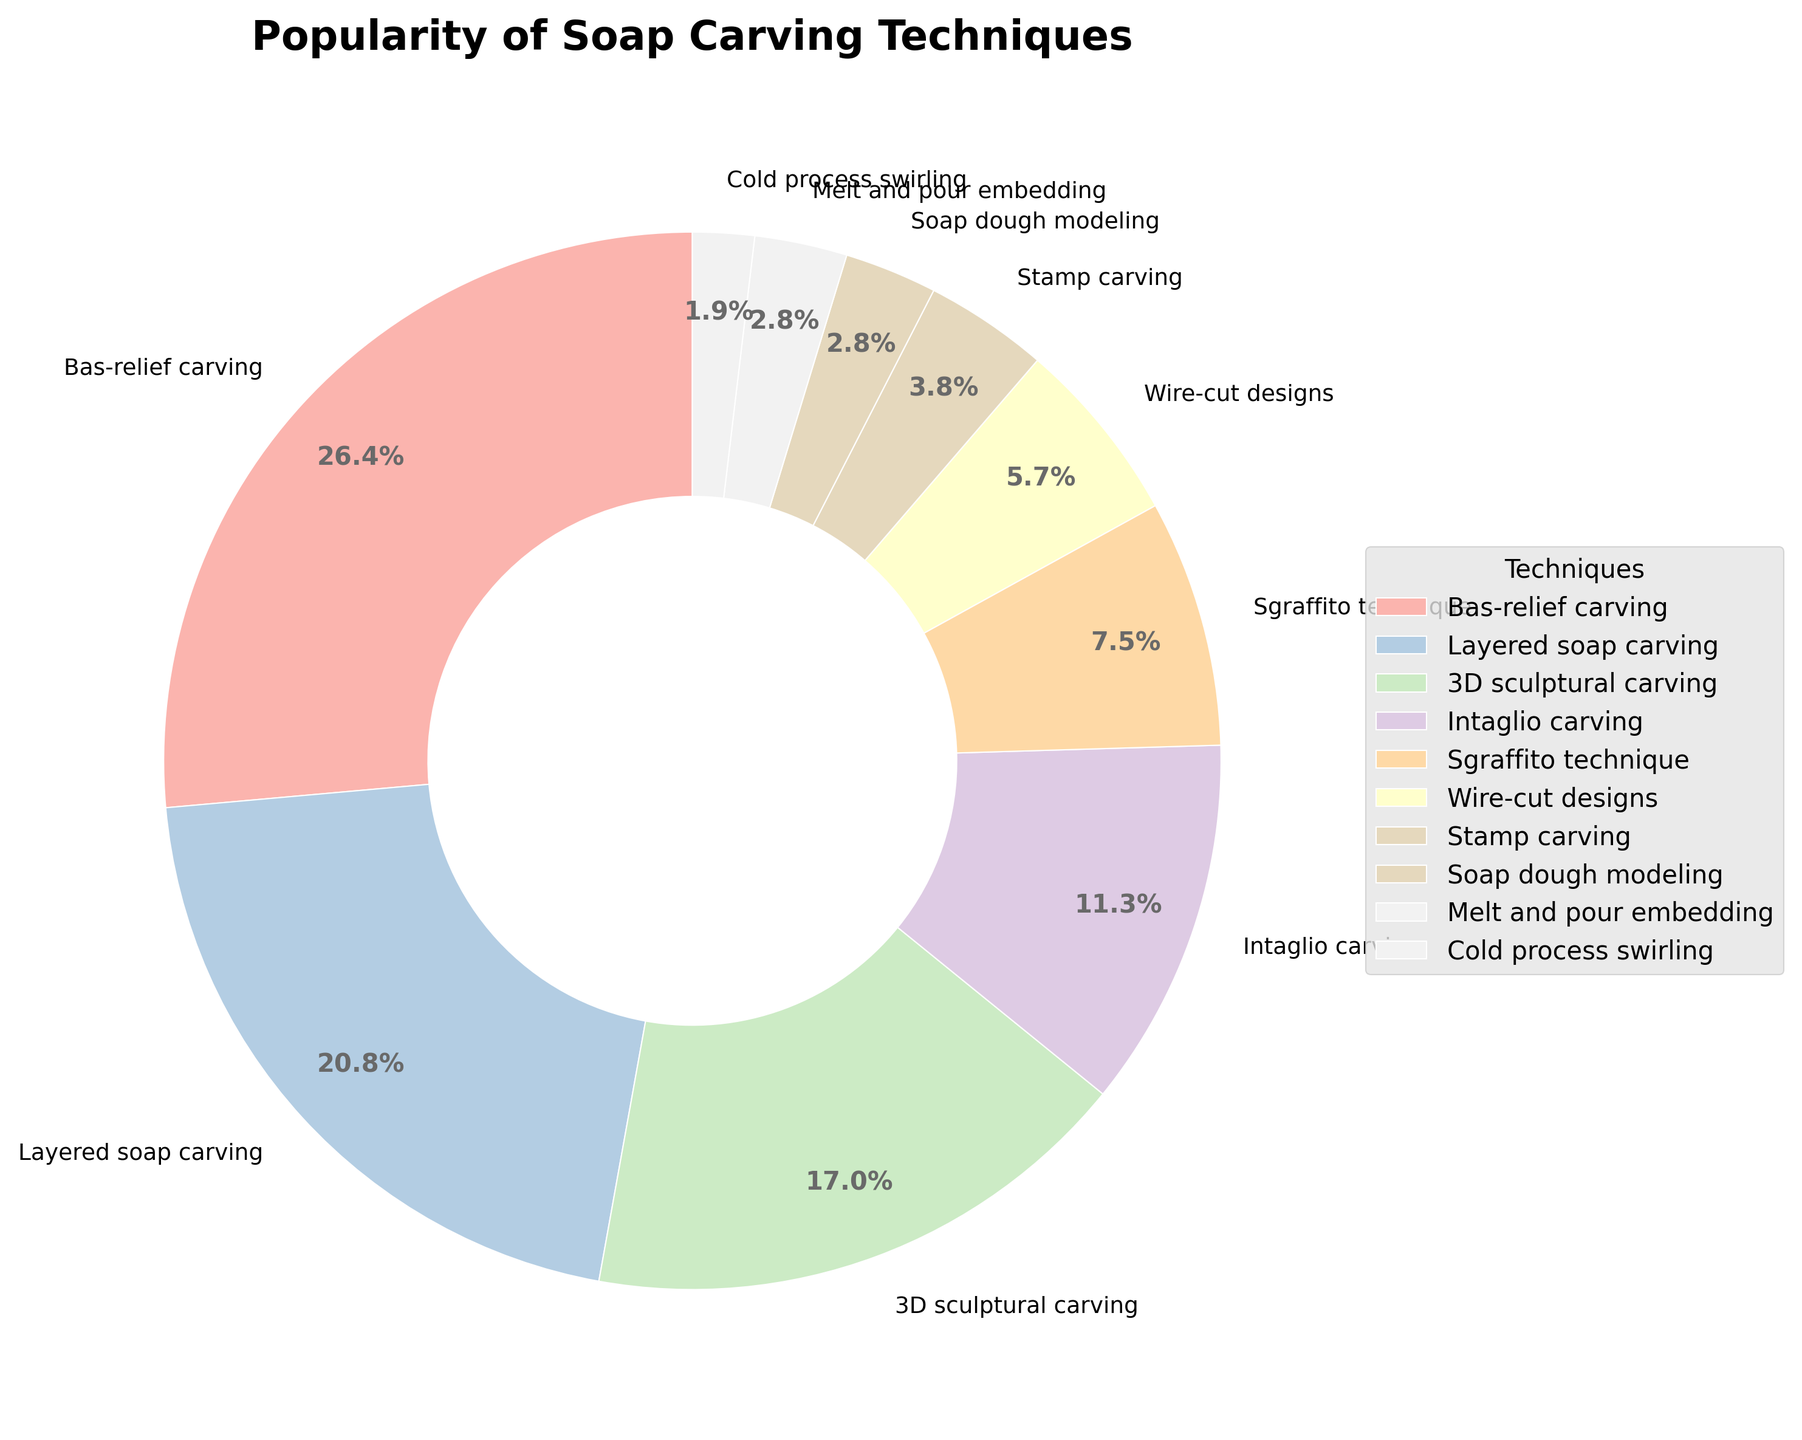Which soap carving technique is the most popular? To determine the most popular technique, we look at the segment of the pie chart with the largest percentage. Bas-relief carving occupies the largest segment with 28%.
Answer: Bas-relief carving How much more popular is layered soap carving compared to wire-cut designs? Layered soap carving has 22% while wire-cut designs have 6%. Subtracting the percentage of wire-cut designs from layered soap carving gives us the difference: 22% - 6% = 16%.
Answer: 16% Which two techniques combined account for less than 10% of the total? By examining the pie chart, we find that Stamp carving and Soap dough modeling both have percentages that sum up to less than 10%. Specifically, Stamp carving has 4% and Soap dough modeling has 3%. 4% + 3% = 7%.
Answer: Stamp carving and Soap dough modeling What is the total percentage for Intaglio carving, Sgraffito technique, and Cold process swirling combined? Adding the percentages for Intaglio carving (12%), Sgraffito technique (8%), and Cold process swirling (2%): 12% + 8% + 2% = 22%.
Answer: 22% Which technique has exactly 3% popularity, and what might that suggest about its niche compared to others? Both Soap dough modeling and Melt and pour embedding have 3% popularity. This suggests these techniques might be more niche and specialized compared to more popular methods.
Answer: Soap dough modeling and Melt and pour embedding Is 3D sculptural carving more popular than Intaglio carving? Looking at the pie chart, 3D sculptural carving has 18% and Intaglio carving has 12%. Since 18% is greater than 12%, 3D sculptural carving is more popular.
Answer: Yes How do the percentages of Bas-relief carving and Layered soap carving together compare to the rest of the techniques? Adding the percentages of Bas-relief carving (28%) and Layered soap carving (22%): 28% + 22% = 50%. The rest of the techniques together make up 100% - 50% = 50%, meaning they are equal.
Answer: Equal Sort the techniques in descending order of their popularity. Bas-relief carving (28%), Layered soap carving (22%), 3D sculptural carving (18%), Intaglio carving (12%), Sgraffito technique (8%), Wire-cut designs (6%), Stamp carving (4%), Soap dough modeling (3%), Melt and pour embedding (3%), Cold process swirling (2%).
Answer: Bas-relief carving, Layered soap carving, 3D sculptural carving, Intaglio carving, Sgraffito technique, Wire-cut designs, Stamp carving, Soap dough modeling, Melt and pour embedding, Cold process swirling Which technique has a popularity percentage closest to the average popularity percentage among all techniques? First, we calculate the average percentage: (28 + 22 + 18 + 12 + 8 + 6 + 4 + 3 + 3 + 2) / 10 = 10.6%. Intaglio carving with 12% is closest to this average.
Answer: Intaglio carving 